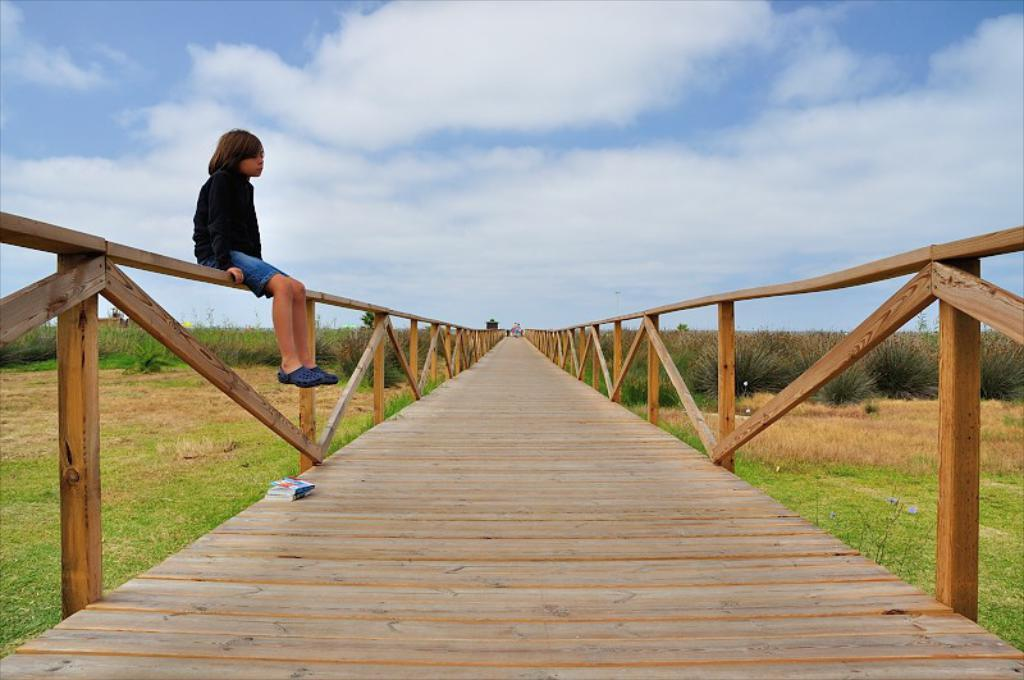What is the main subject of the image? The main subject of the image is a kid. What is the kid wearing? The kid is wearing a black dress. Where is the kid sitting? The kid is sitting on the fence of a wooden bridge. What can be seen on either side of the bridge? There is grassland on either side of the bridge. What is visible in the sky? The sky is visible in the image, and clouds are present. What type of idea can be seen floating in the sky in the image? There is no idea visible in the image; only the kid, the bridge, the grassland, and the sky with clouds are present. 